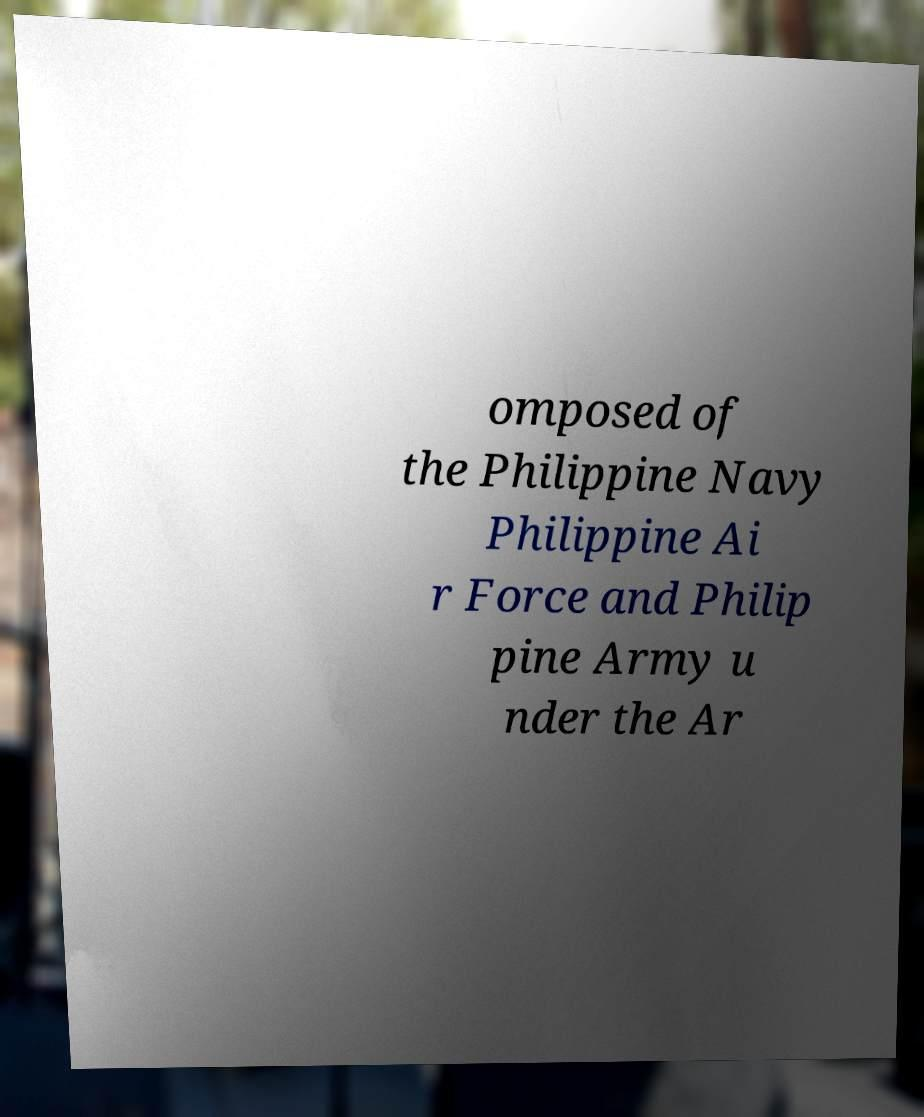Can you accurately transcribe the text from the provided image for me? omposed of the Philippine Navy Philippine Ai r Force and Philip pine Army u nder the Ar 